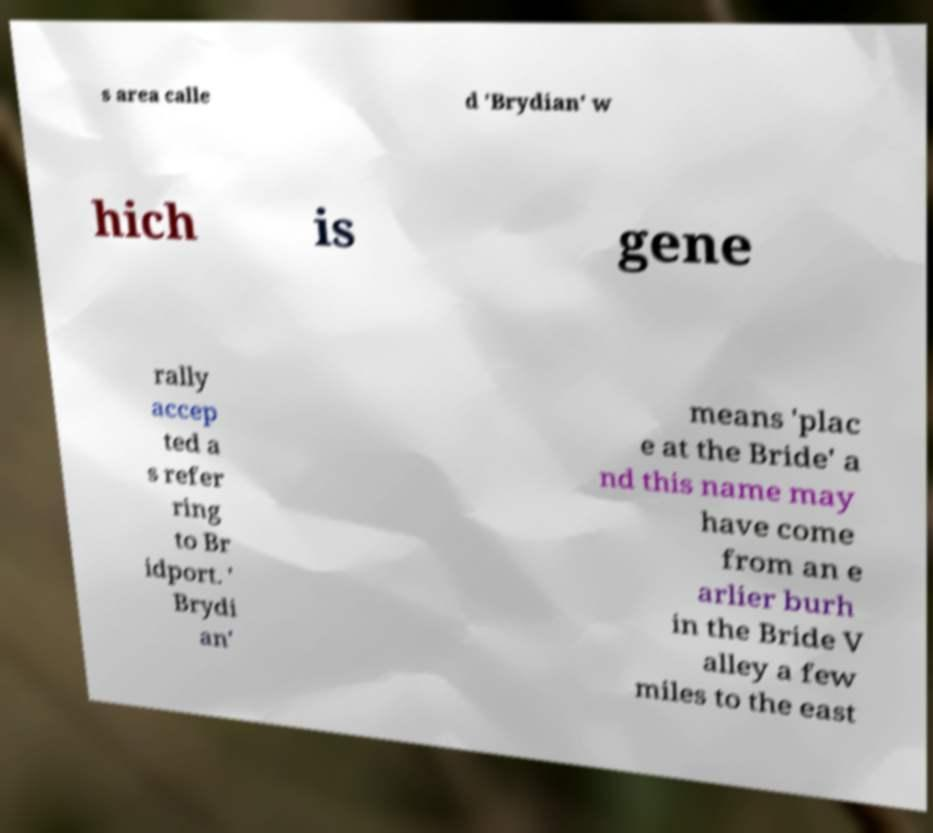What messages or text are displayed in this image? I need them in a readable, typed format. s area calle d 'Brydian' w hich is gene rally accep ted a s refer ring to Br idport. ' Brydi an' means 'plac e at the Bride' a nd this name may have come from an e arlier burh in the Bride V alley a few miles to the east 